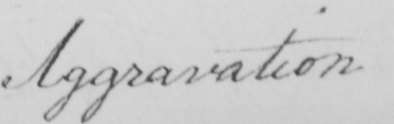Please provide the text content of this handwritten line. Aggravation 